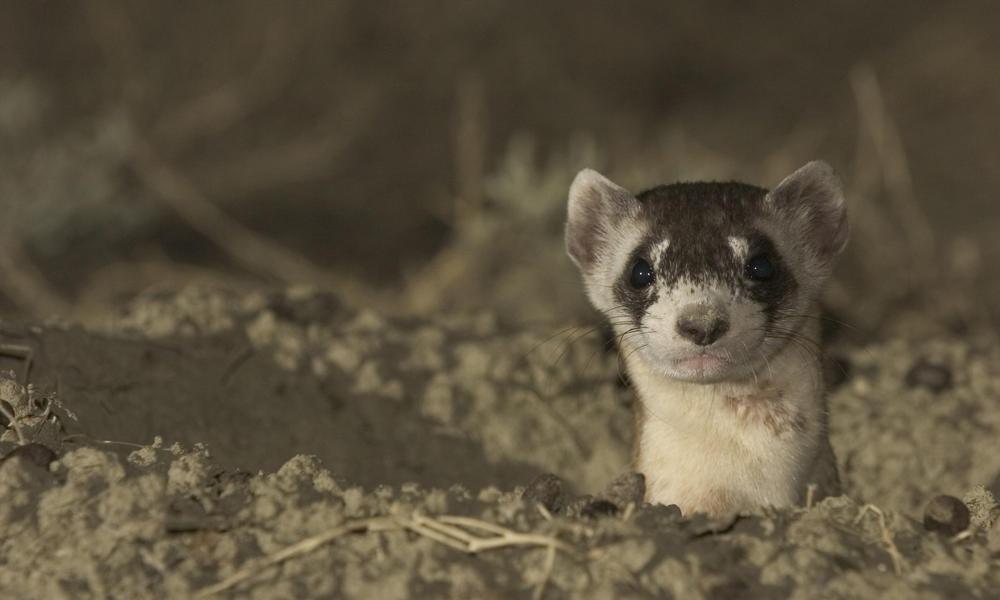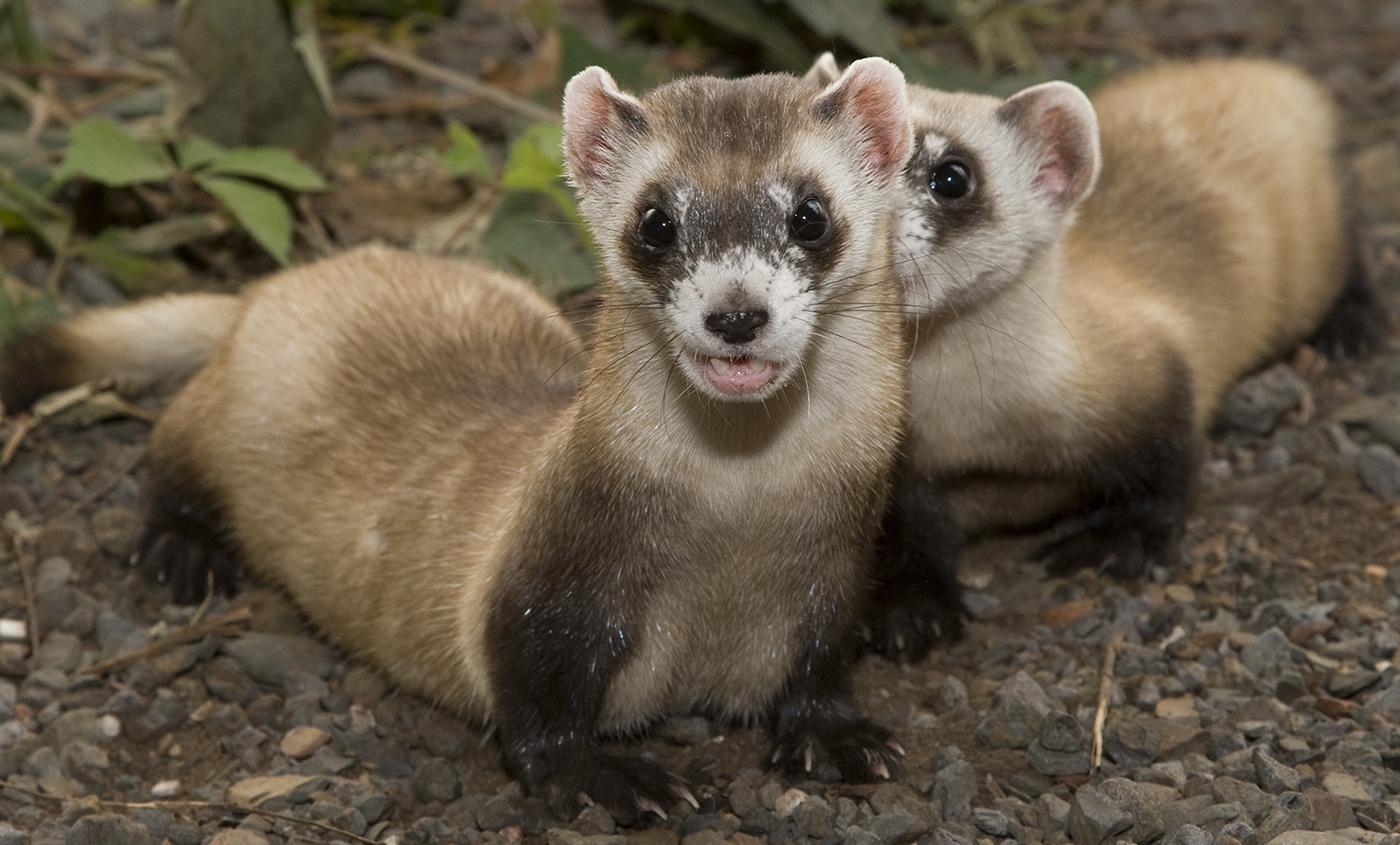The first image is the image on the left, the second image is the image on the right. For the images shown, is this caption "An image contains a prairie dog coming out of a hole." true? Answer yes or no. Yes. The first image is the image on the left, the second image is the image on the right. Analyze the images presented: Is the assertion "Each image contains one ferret, and no ferrets are emerging from a hole in the ground." valid? Answer yes or no. No. 